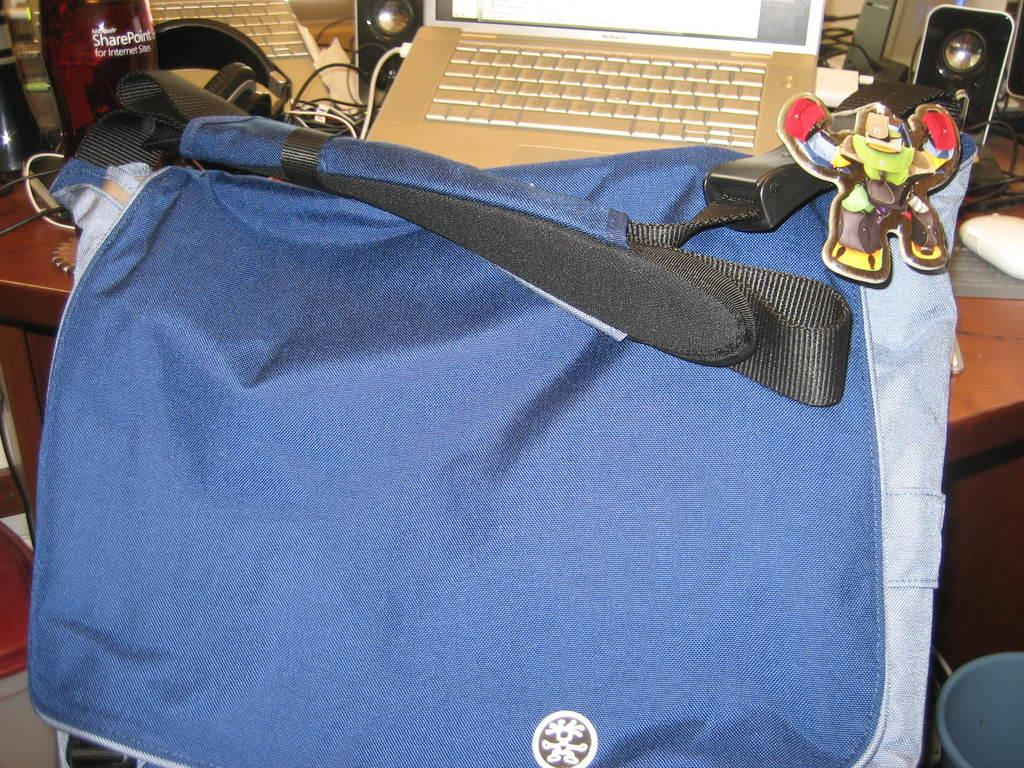What electronic device is visible in the image? There is a laptop in the image. What type of container is present in the image? There is a bottle in the image. What type of audio accessory is in the image? There are headphones in the image. What type of clothing accessory is in the image? There is a belt in the image. What color is the crayon used to draw on the laptop in the image? There is no crayon or drawing present on the laptop in the image. How many goldfish are swimming in the bottle in the image? There are no goldfish present in the image, as it features a laptop, a bottle, headphones, and a belt. 